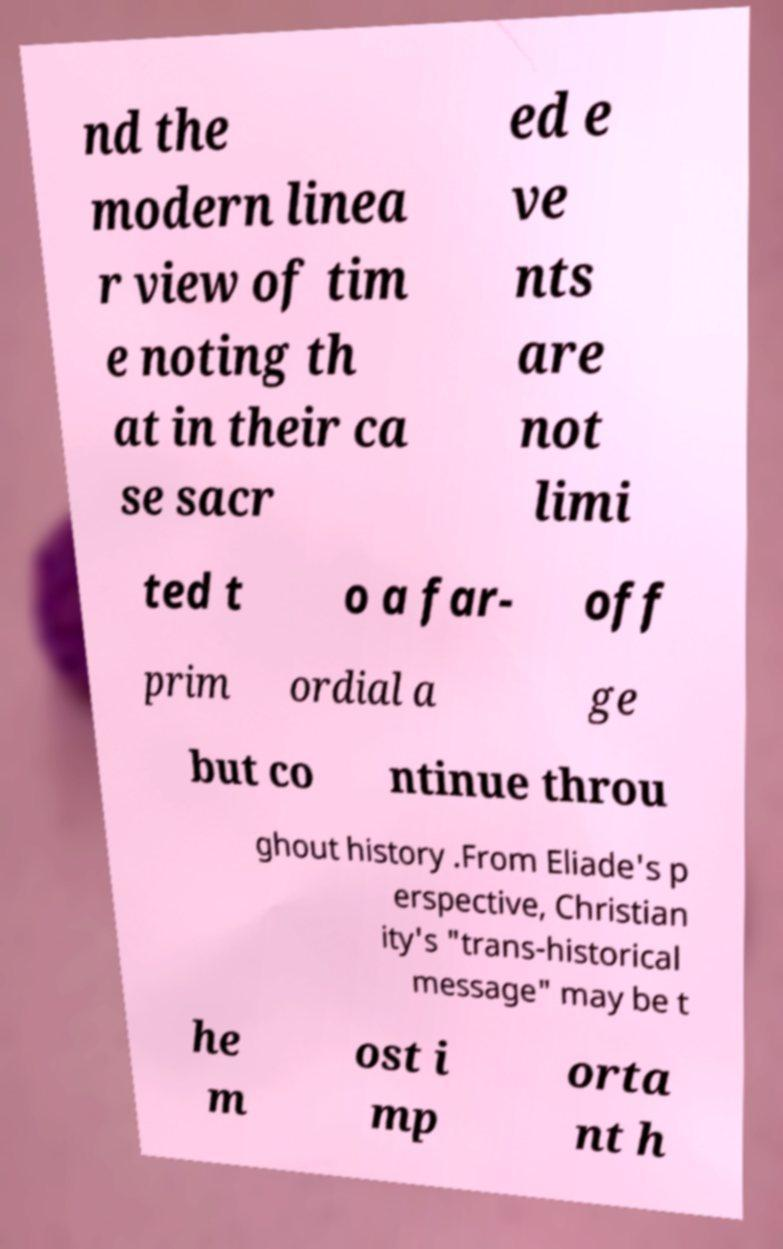Can you read and provide the text displayed in the image?This photo seems to have some interesting text. Can you extract and type it out for me? nd the modern linea r view of tim e noting th at in their ca se sacr ed e ve nts are not limi ted t o a far- off prim ordial a ge but co ntinue throu ghout history .From Eliade's p erspective, Christian ity's "trans-historical message" may be t he m ost i mp orta nt h 